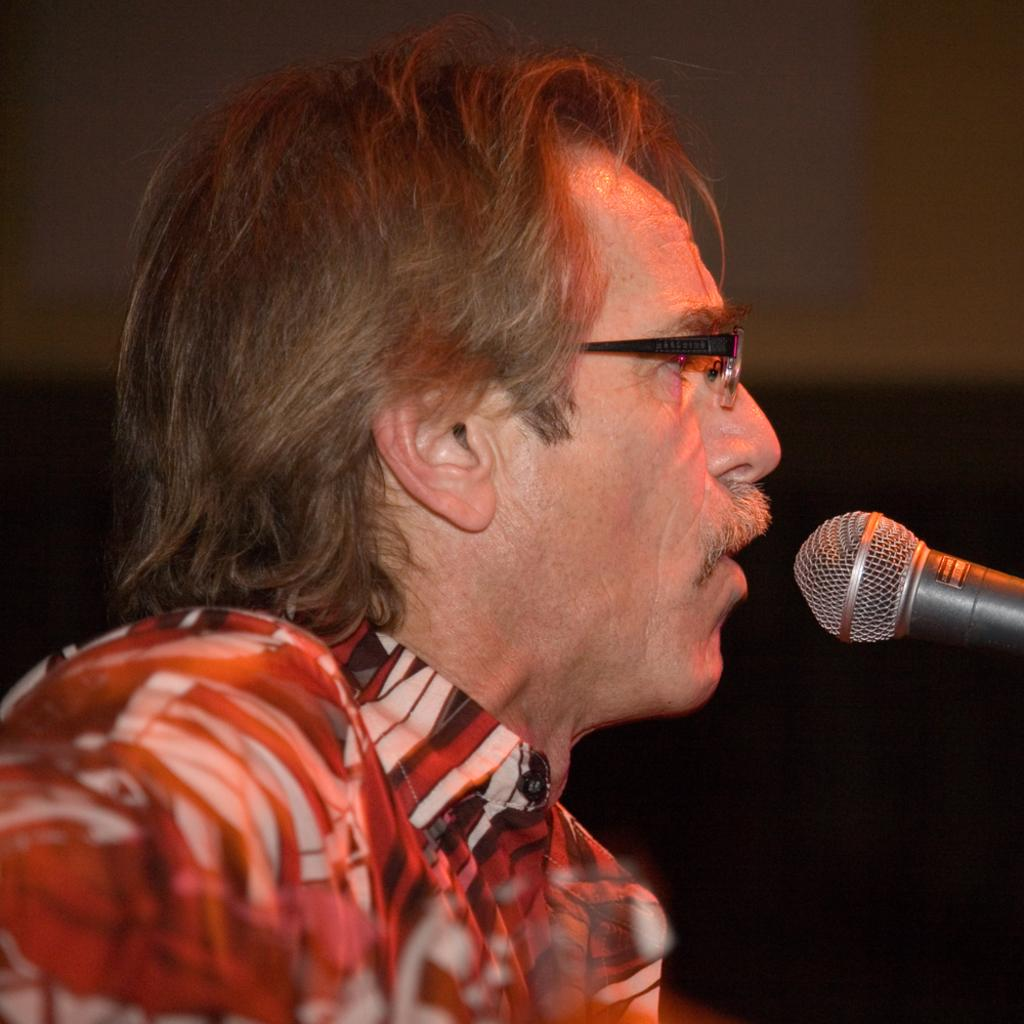Who or what is the main subject in the image? There is a person in the image. What object is in front of the person? There is a microphone (mike) in front of the person. What can be seen behind the person? There is a wall in the background of the image. What type of turkey is being prepared in the image? There is no turkey present in the image; it features a person with a microphone in front of them and a wall in the background. 